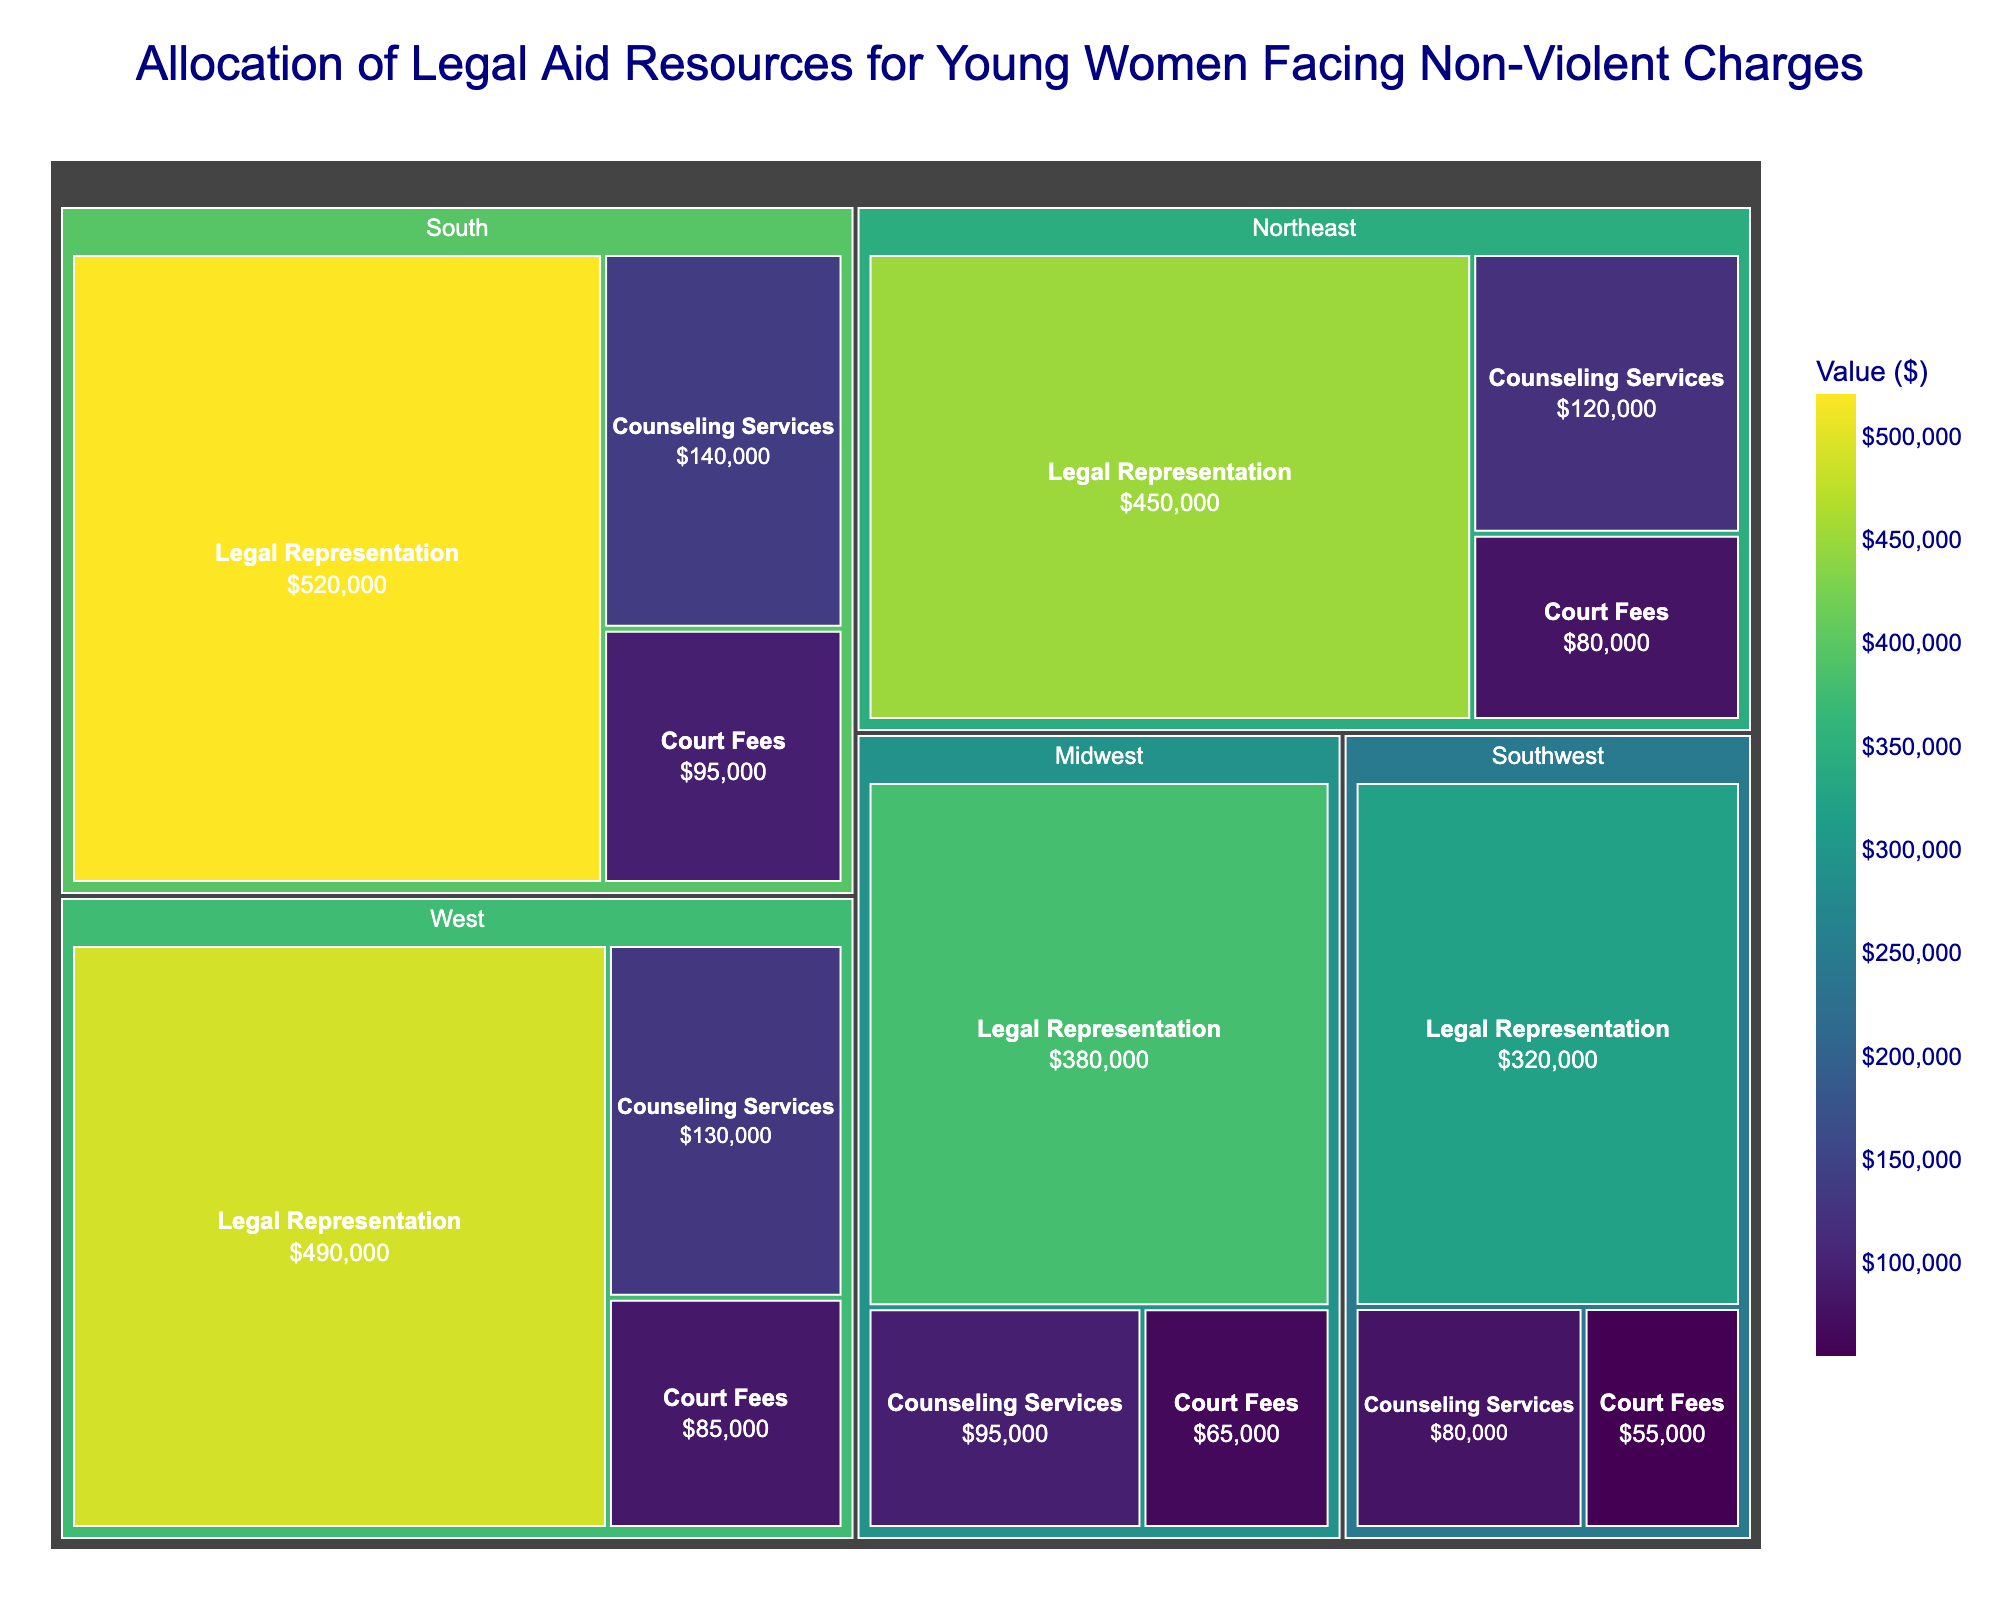Which region has allocated the most resources towards legal representation? Look for the region with the largest value in legal representation. The South has allocated $520,000, which is the highest among all the regions.
Answer: South What is the total amount allocated for court fees across all regions? Sum up the values for court fees in all regions: $80,000 (Northeast) + $65,000 (Midwest) + $95,000 (South) + $85,000 (West) + $55,000 (Southwest) = $380,000.
Answer: $380,000 Which type of assistance has the lowest allocation in the Midwest? Compare the values for each type of assistance in the Midwest. Legal Representation is $380,000, Court Fees are $65,000, and Counseling Services are $95,000. The lowest is Court Fees with $65,000.
Answer: Court Fees How does the allocation for counseling services in the West compare to the South? Compare the values for counseling services between the two regions. West has allocated $130,000 and South has allocated $140,000. The West has $10,000 less than the South.
Answer: $10,000 less What percentage of the total resources allocated in the Northeast is for legal representation? Calculate the total resources allocated in the Northeast: $450,000 (Legal Representation) + $80,000 (Court Fees) + $120,000 (Counseling Services) = $650,000. Then calculate the percentage for legal representation: ($450,000 / $650,000) * 100 = 69.23%.
Answer: 69.23% Which region has the smallest total allocation for all types of assistance? Calculate the total allocation for each region and compare. 
Northeast: $450,000 + $80,000 + $120,000 = $650,000
Midwest: $380,000 + $65,000 + $95,000 = $540,000
South: $520,000 + $95,000 + $140,000 = $755,000
West: $490,000 + $85,000 + $130,000 = $705,000
Southwest: $320,000 + $55,000 + $80,000 = $455,000
The Southwest has the smallest total allocation of $455,000.
Answer: Southwest Rank the regions from highest to lowest based on their allocation for counseling services. Compare the values for counseling services in each region and rank them.
South: $140,000
West: $130,000
Northeast: $120,000
Midwest: $95,000
Southwest: $80,000
Answer: South, West, Northeast, Midwest, Southwest 